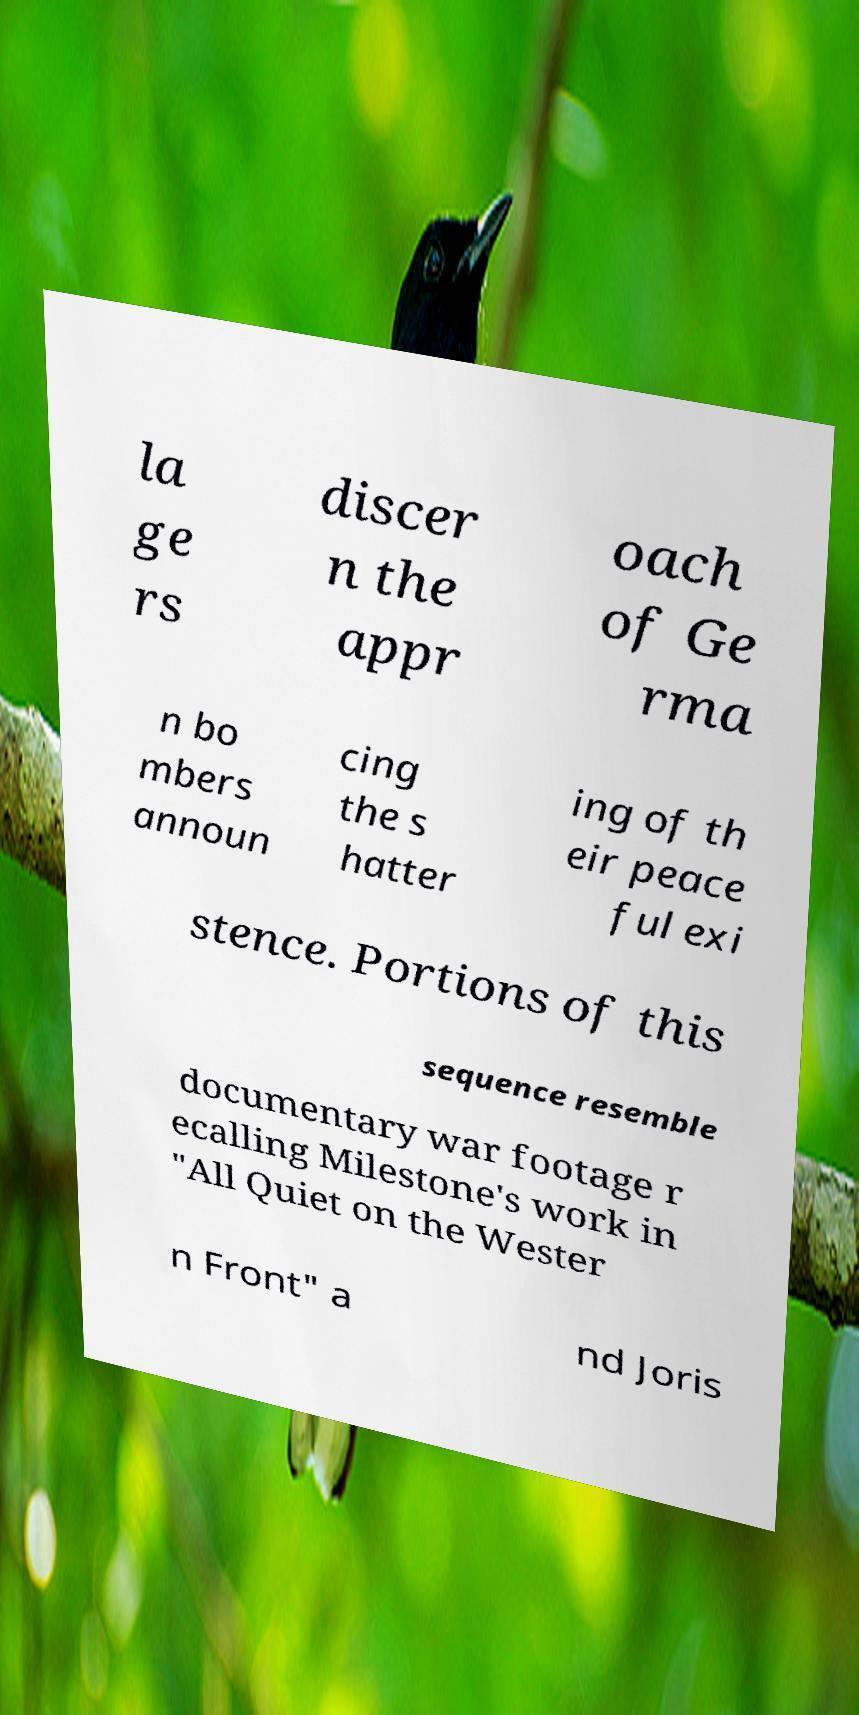I need the written content from this picture converted into text. Can you do that? la ge rs discer n the appr oach of Ge rma n bo mbers announ cing the s hatter ing of th eir peace ful exi stence. Portions of this sequence resemble documentary war footage r ecalling Milestone's work in "All Quiet on the Wester n Front" a nd Joris 